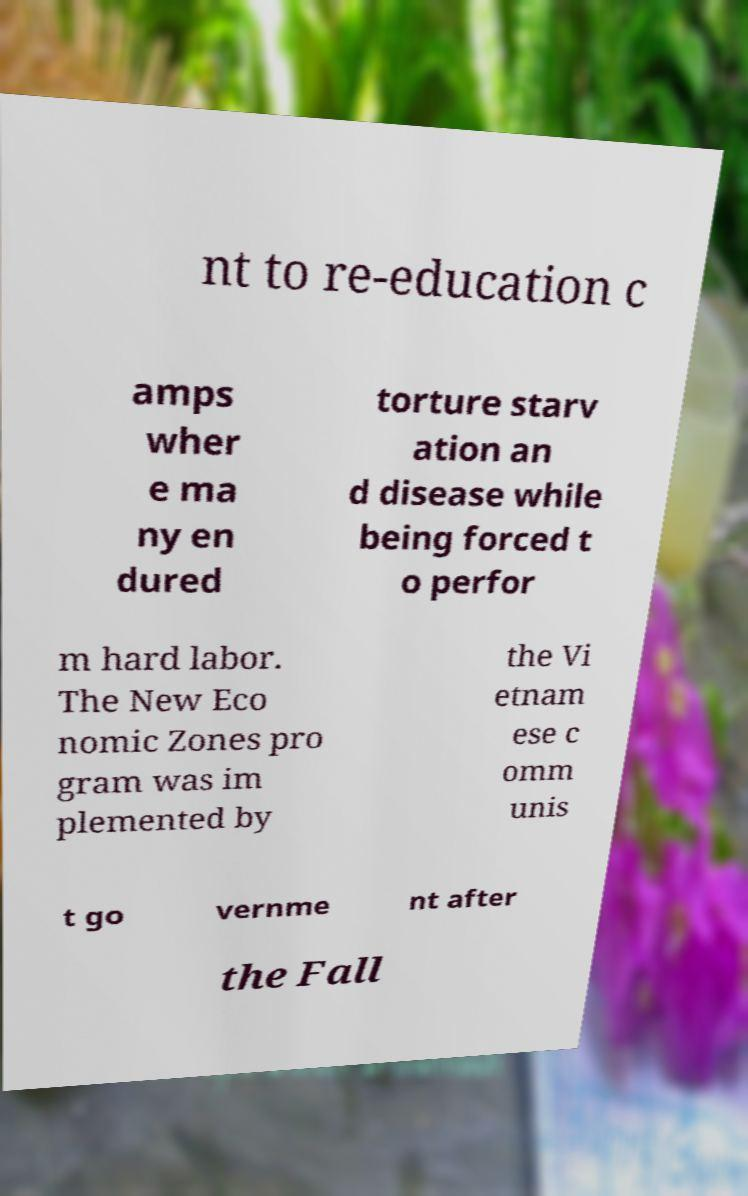Please identify and transcribe the text found in this image. nt to re-education c amps wher e ma ny en dured torture starv ation an d disease while being forced t o perfor m hard labor. The New Eco nomic Zones pro gram was im plemented by the Vi etnam ese c omm unis t go vernme nt after the Fall 